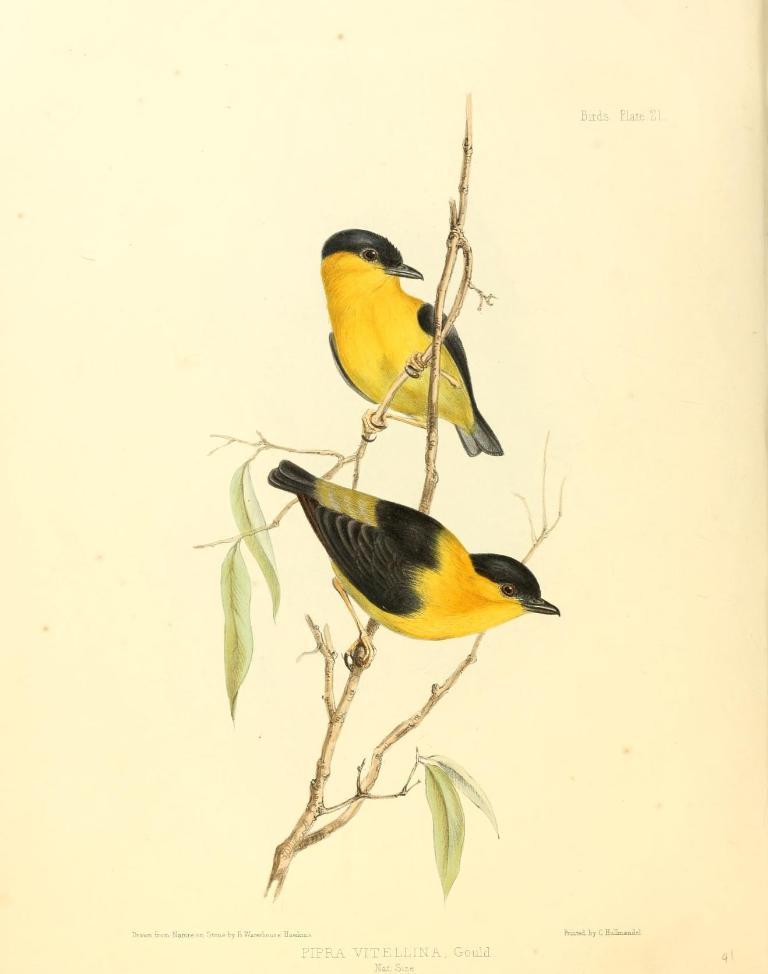Can you describe this image briefly? This is the page of a book were we can see two birds are sitting on the stem of a plant. 